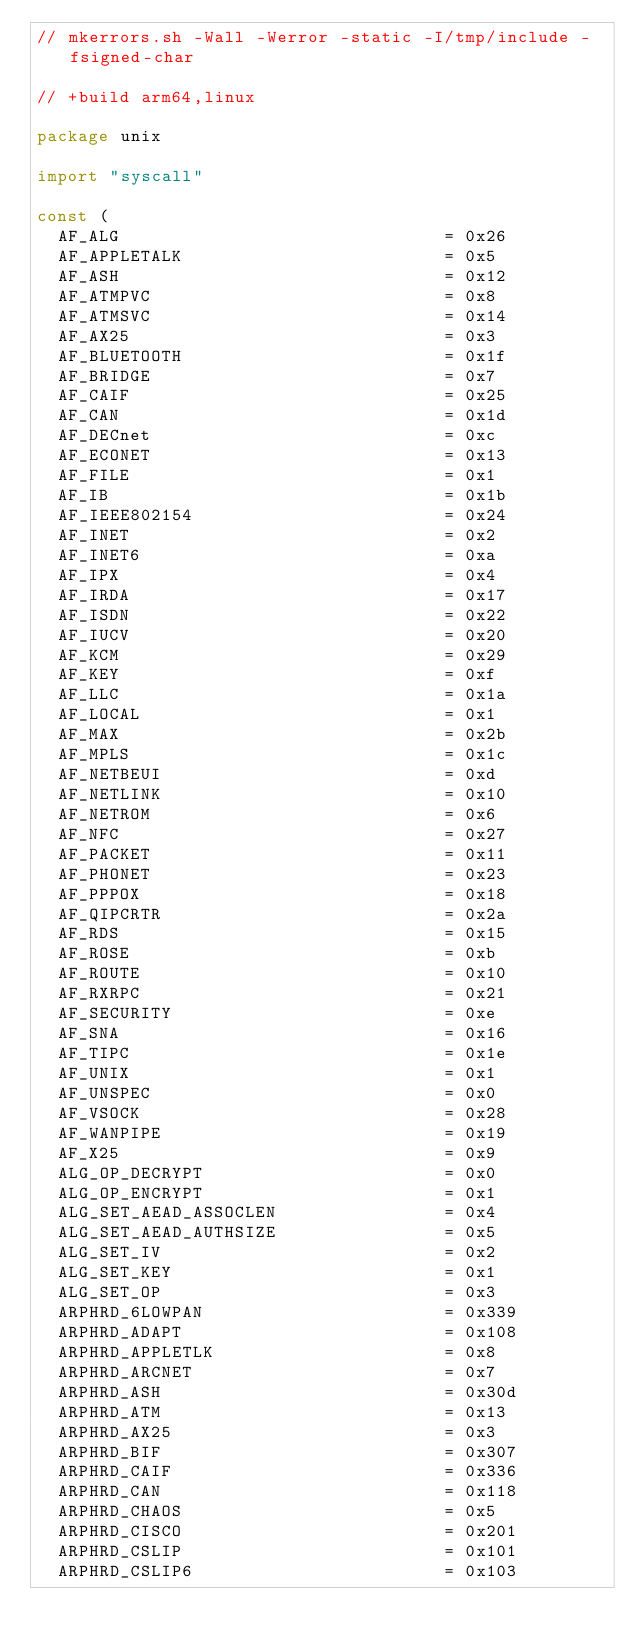<code> <loc_0><loc_0><loc_500><loc_500><_Go_>// mkerrors.sh -Wall -Werror -static -I/tmp/include -fsigned-char

// +build arm64,linux

package unix

import "syscall"

const (
	AF_ALG                               = 0x26
	AF_APPLETALK                         = 0x5
	AF_ASH                               = 0x12
	AF_ATMPVC                            = 0x8
	AF_ATMSVC                            = 0x14
	AF_AX25                              = 0x3
	AF_BLUETOOTH                         = 0x1f
	AF_BRIDGE                            = 0x7
	AF_CAIF                              = 0x25
	AF_CAN                               = 0x1d
	AF_DECnet                            = 0xc
	AF_ECONET                            = 0x13
	AF_FILE                              = 0x1
	AF_IB                                = 0x1b
	AF_IEEE802154                        = 0x24
	AF_INET                              = 0x2
	AF_INET6                             = 0xa
	AF_IPX                               = 0x4
	AF_IRDA                              = 0x17
	AF_ISDN                              = 0x22
	AF_IUCV                              = 0x20
	AF_KCM                               = 0x29
	AF_KEY                               = 0xf
	AF_LLC                               = 0x1a
	AF_LOCAL                             = 0x1
	AF_MAX                               = 0x2b
	AF_MPLS                              = 0x1c
	AF_NETBEUI                           = 0xd
	AF_NETLINK                           = 0x10
	AF_NETROM                            = 0x6
	AF_NFC                               = 0x27
	AF_PACKET                            = 0x11
	AF_PHONET                            = 0x23
	AF_PPPOX                             = 0x18
	AF_QIPCRTR                           = 0x2a
	AF_RDS                               = 0x15
	AF_ROSE                              = 0xb
	AF_ROUTE                             = 0x10
	AF_RXRPC                             = 0x21
	AF_SECURITY                          = 0xe
	AF_SNA                               = 0x16
	AF_TIPC                              = 0x1e
	AF_UNIX                              = 0x1
	AF_UNSPEC                            = 0x0
	AF_VSOCK                             = 0x28
	AF_WANPIPE                           = 0x19
	AF_X25                               = 0x9
	ALG_OP_DECRYPT                       = 0x0
	ALG_OP_ENCRYPT                       = 0x1
	ALG_SET_AEAD_ASSOCLEN                = 0x4
	ALG_SET_AEAD_AUTHSIZE                = 0x5
	ALG_SET_IV                           = 0x2
	ALG_SET_KEY                          = 0x1
	ALG_SET_OP                           = 0x3
	ARPHRD_6LOWPAN                       = 0x339
	ARPHRD_ADAPT                         = 0x108
	ARPHRD_APPLETLK                      = 0x8
	ARPHRD_ARCNET                        = 0x7
	ARPHRD_ASH                           = 0x30d
	ARPHRD_ATM                           = 0x13
	ARPHRD_AX25                          = 0x3
	ARPHRD_BIF                           = 0x307
	ARPHRD_CAIF                          = 0x336
	ARPHRD_CAN                           = 0x118
	ARPHRD_CHAOS                         = 0x5
	ARPHRD_CISCO                         = 0x201
	ARPHRD_CSLIP                         = 0x101
	ARPHRD_CSLIP6                        = 0x103</code> 